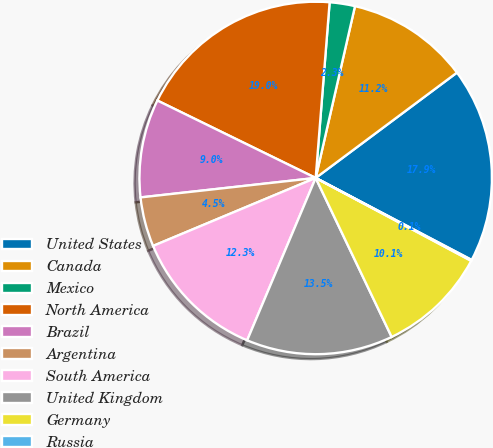Convert chart to OTSL. <chart><loc_0><loc_0><loc_500><loc_500><pie_chart><fcel>United States<fcel>Canada<fcel>Mexico<fcel>North America<fcel>Brazil<fcel>Argentina<fcel>South America<fcel>United Kingdom<fcel>Germany<fcel>Russia<nl><fcel>17.9%<fcel>11.22%<fcel>2.32%<fcel>19.02%<fcel>9.0%<fcel>4.54%<fcel>12.34%<fcel>13.45%<fcel>10.11%<fcel>0.09%<nl></chart> 